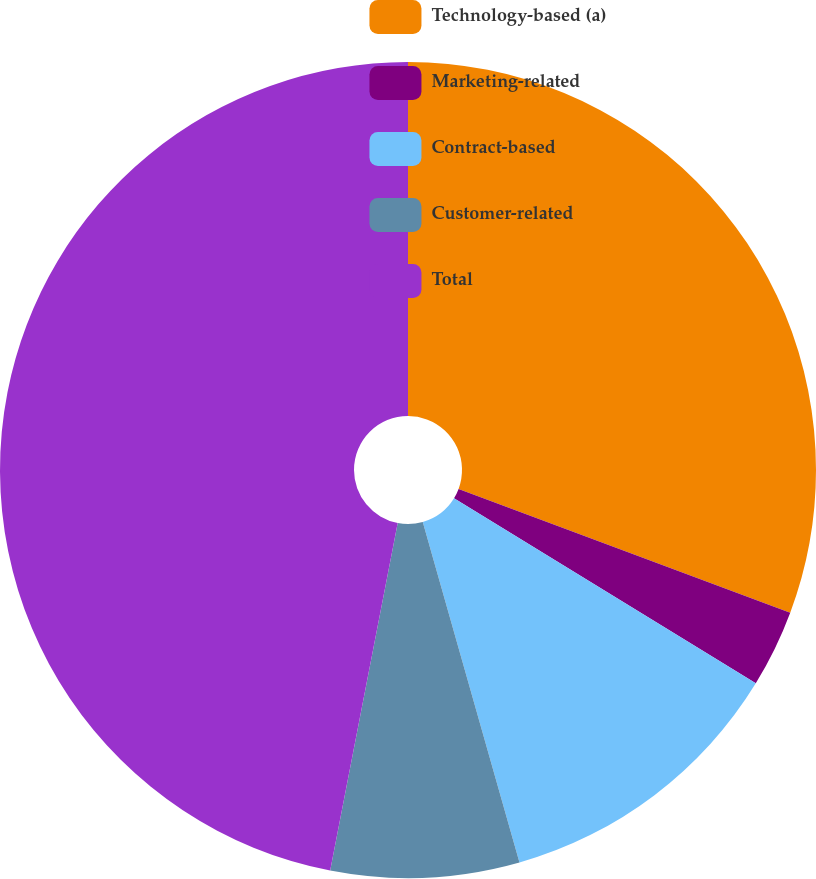Convert chart to OTSL. <chart><loc_0><loc_0><loc_500><loc_500><pie_chart><fcel>Technology-based (a)<fcel>Marketing-related<fcel>Contract-based<fcel>Customer-related<fcel>Total<nl><fcel>30.69%<fcel>3.07%<fcel>11.84%<fcel>7.46%<fcel>46.95%<nl></chart> 